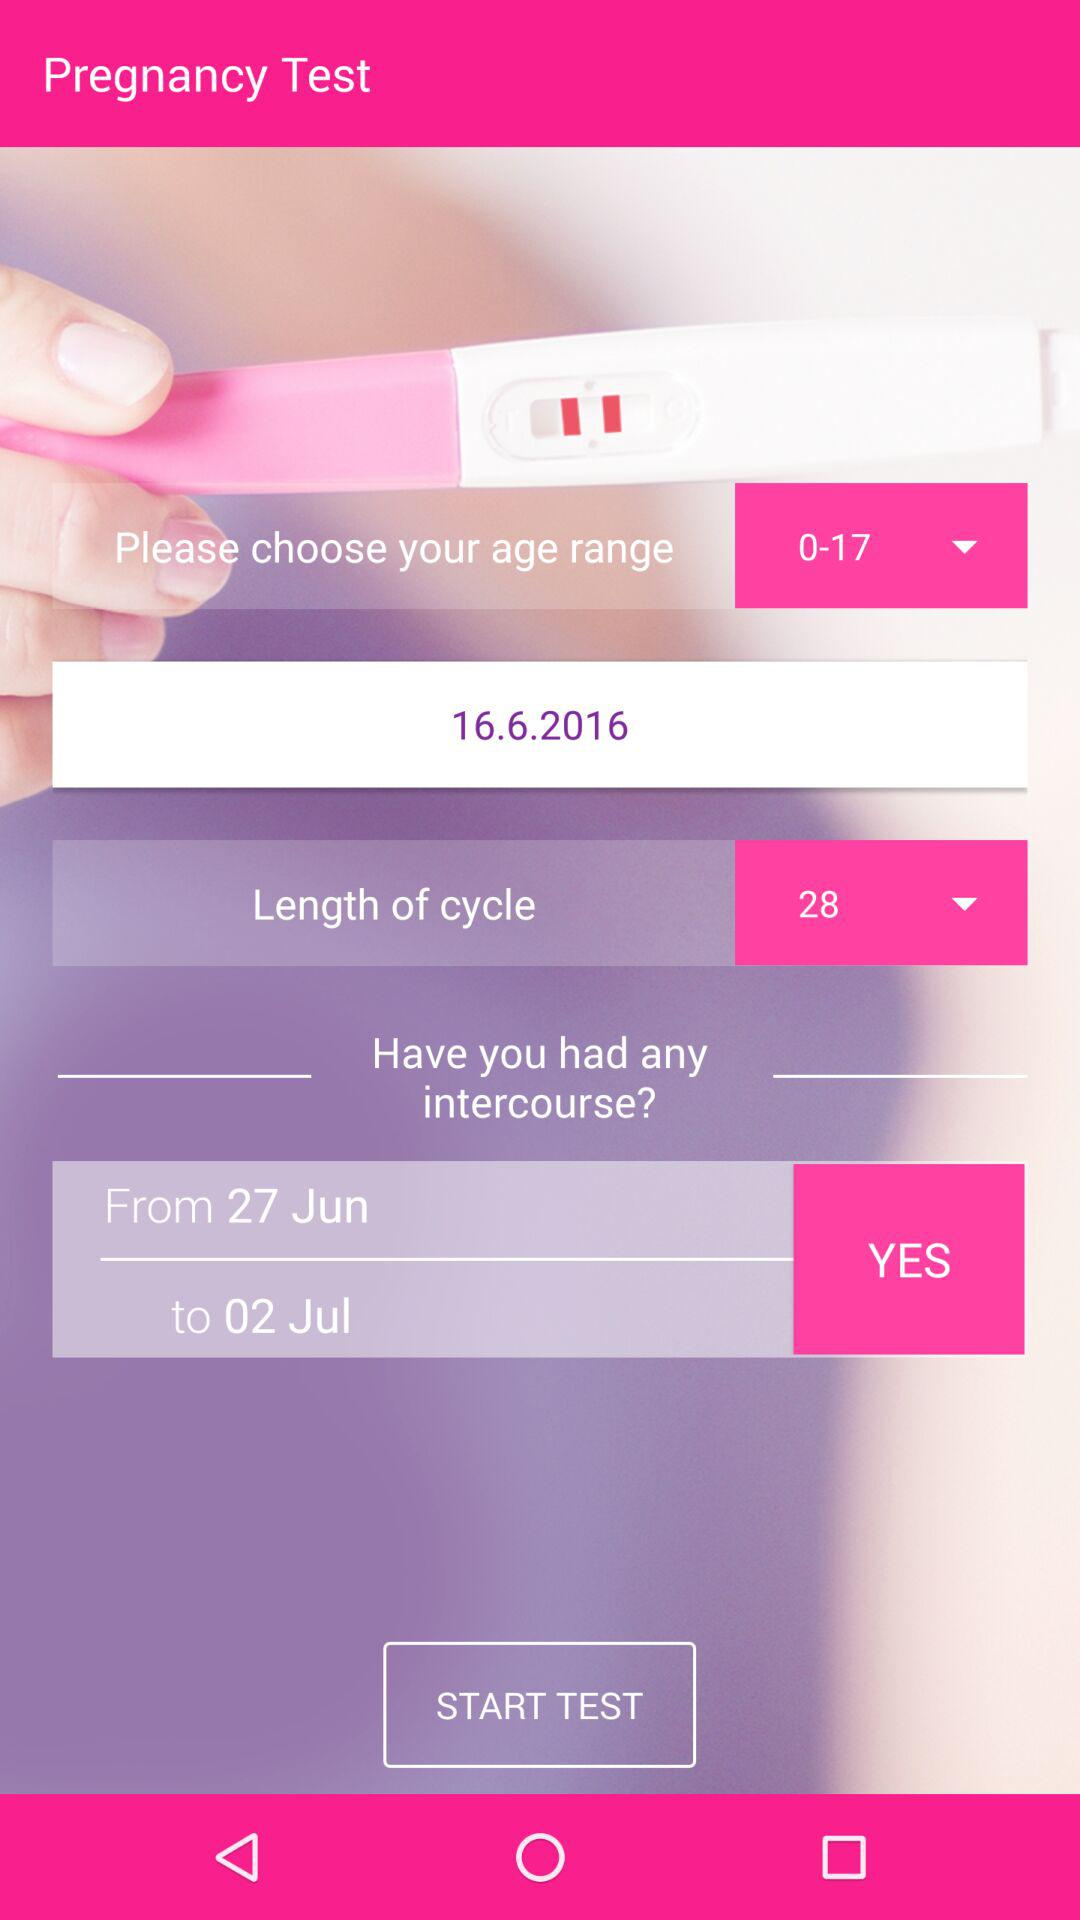What is the selected age range? The selected age range is from 0 to 17. 